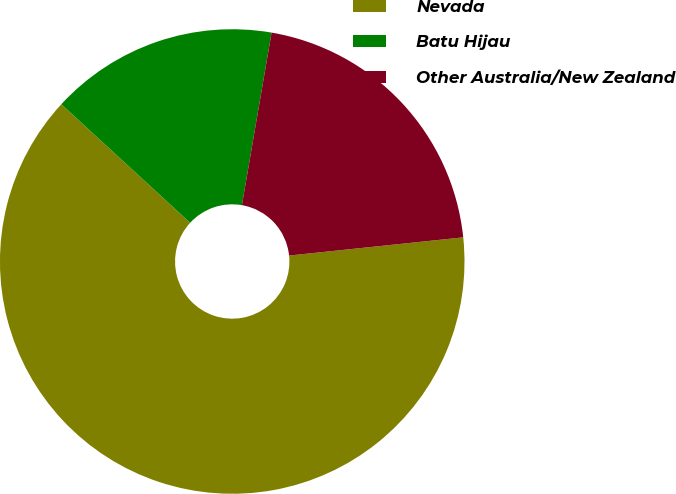Convert chart to OTSL. <chart><loc_0><loc_0><loc_500><loc_500><pie_chart><fcel>Nevada<fcel>Batu Hijau<fcel>Other Australia/New Zealand<nl><fcel>63.49%<fcel>15.87%<fcel>20.63%<nl></chart> 